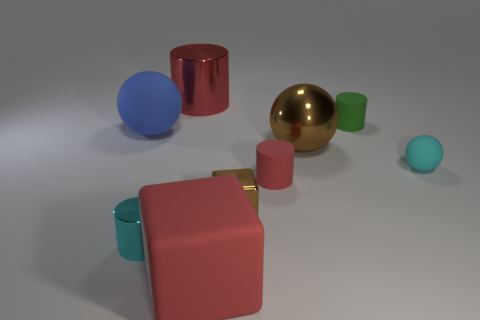Add 1 small cyan cylinders. How many objects exist? 10 Subtract 0 gray balls. How many objects are left? 9 Subtract all cylinders. How many objects are left? 5 Subtract all large blue rubber objects. Subtract all cyan metal cylinders. How many objects are left? 7 Add 7 big red cylinders. How many big red cylinders are left? 8 Add 7 small cyan metal blocks. How many small cyan metal blocks exist? 7 